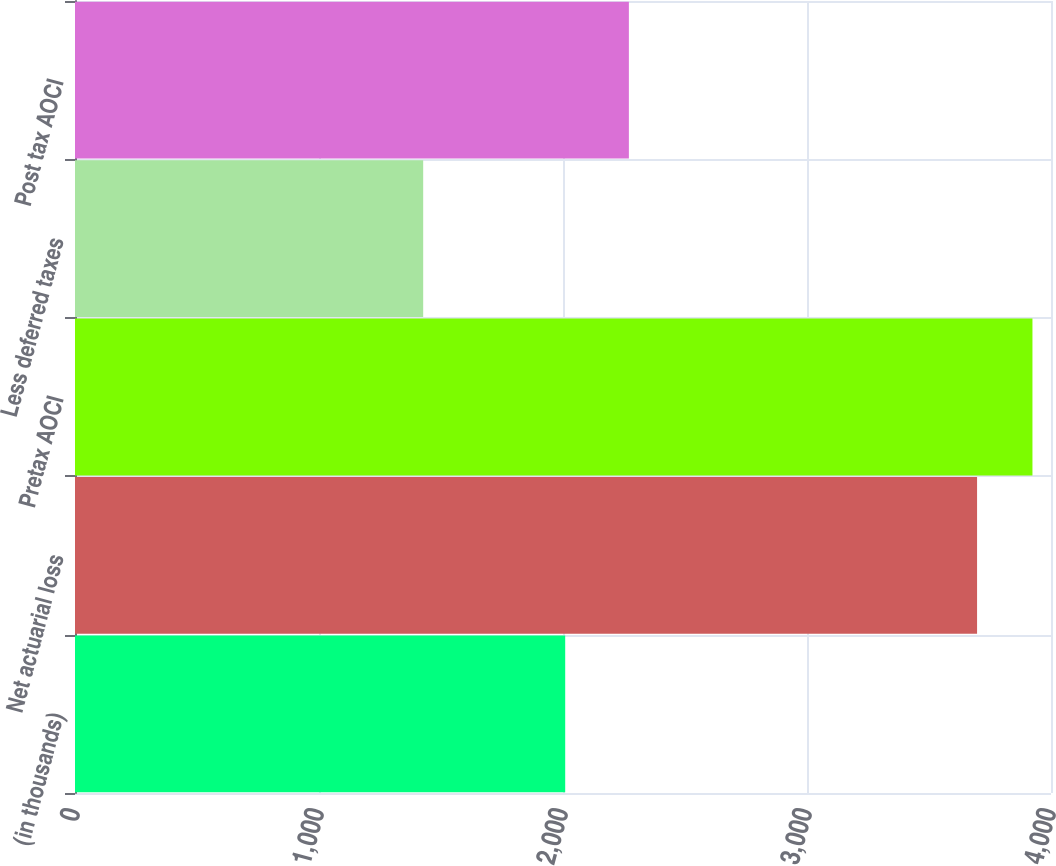Convert chart. <chart><loc_0><loc_0><loc_500><loc_500><bar_chart><fcel>(in thousands)<fcel>Net actuarial loss<fcel>Pretax AOCI<fcel>Less deferred taxes<fcel>Post tax AOCI<nl><fcel>2009<fcel>3697<fcel>3924<fcel>1427<fcel>2270<nl></chart> 